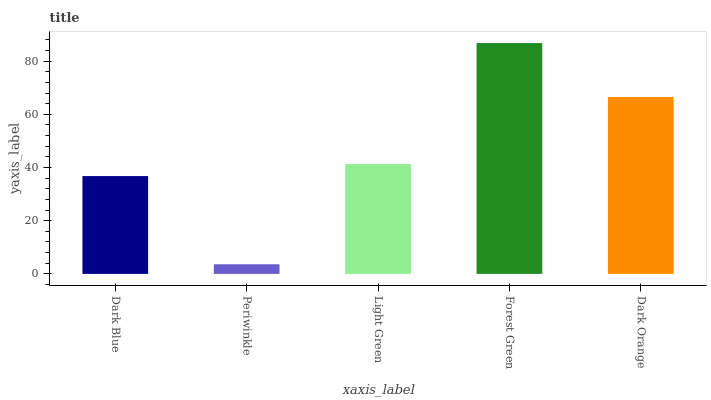Is Periwinkle the minimum?
Answer yes or no. Yes. Is Forest Green the maximum?
Answer yes or no. Yes. Is Light Green the minimum?
Answer yes or no. No. Is Light Green the maximum?
Answer yes or no. No. Is Light Green greater than Periwinkle?
Answer yes or no. Yes. Is Periwinkle less than Light Green?
Answer yes or no. Yes. Is Periwinkle greater than Light Green?
Answer yes or no. No. Is Light Green less than Periwinkle?
Answer yes or no. No. Is Light Green the high median?
Answer yes or no. Yes. Is Light Green the low median?
Answer yes or no. Yes. Is Forest Green the high median?
Answer yes or no. No. Is Dark Orange the low median?
Answer yes or no. No. 